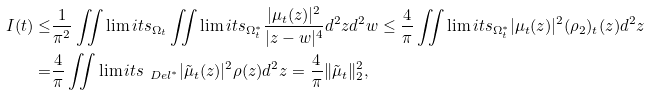<formula> <loc_0><loc_0><loc_500><loc_500>I ( t ) \leq & \frac { 1 } { \pi ^ { 2 } } \iint \lim i t s _ { \Omega _ { t } } \iint \lim i t s _ { \Omega _ { t } ^ { * } } \frac { | \mu _ { t } ( z ) | ^ { 2 } } { | z - w | ^ { 4 } } d ^ { 2 } z d ^ { 2 } w \leq \frac { 4 } { \pi } \iint \lim i t s _ { \Omega _ { t } ^ { * } } | \mu _ { t } ( z ) | ^ { 2 } ( \rho _ { 2 } ) _ { t } ( z ) d ^ { 2 } z \\ = & \frac { 4 } { \pi } \iint \lim i t s _ { \ D e l ^ { * } } | \tilde { \mu } _ { t } ( z ) | ^ { 2 } \rho ( z ) d ^ { 2 } z = \frac { 4 } { \pi } \| \tilde { \mu } _ { t } \| _ { 2 } ^ { 2 } ,</formula> 